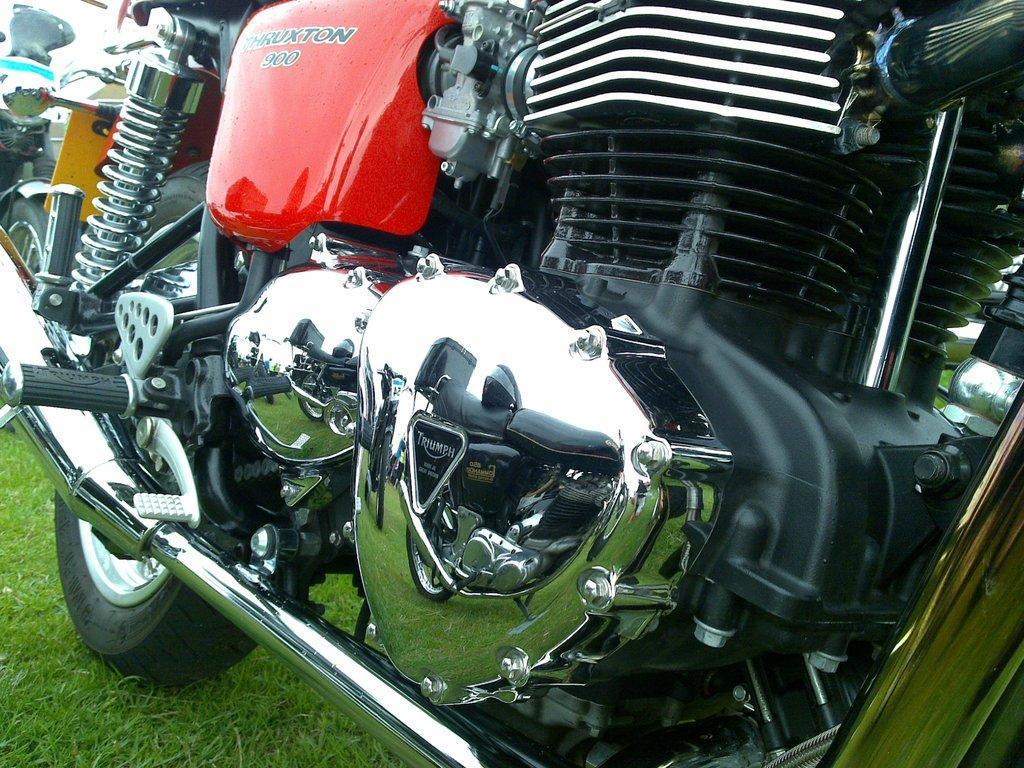How would you summarize this image in a sentence or two? There is a bike in the center of the image on the grassland, it seems like another bike on the left side. 